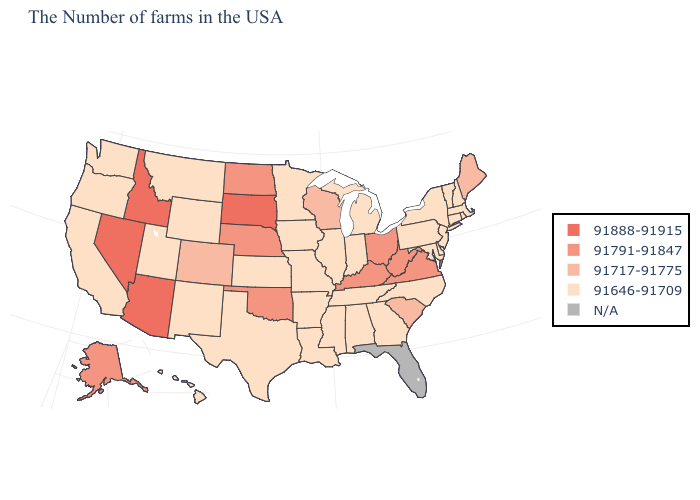Among the states that border Indiana , does Ohio have the highest value?
Quick response, please. Yes. Name the states that have a value in the range 91717-91775?
Answer briefly. Maine, South Carolina, Wisconsin, Colorado. Name the states that have a value in the range 91888-91915?
Quick response, please. South Dakota, Arizona, Idaho, Nevada. Among the states that border Minnesota , does Wisconsin have the lowest value?
Keep it brief. No. Which states hav the highest value in the Northeast?
Give a very brief answer. Maine. What is the highest value in the USA?
Keep it brief. 91888-91915. What is the value of Iowa?
Quick response, please. 91646-91709. Name the states that have a value in the range 91646-91709?
Write a very short answer. Massachusetts, Rhode Island, New Hampshire, Vermont, Connecticut, New York, New Jersey, Delaware, Maryland, Pennsylvania, North Carolina, Georgia, Michigan, Indiana, Alabama, Tennessee, Illinois, Mississippi, Louisiana, Missouri, Arkansas, Minnesota, Iowa, Kansas, Texas, Wyoming, New Mexico, Utah, Montana, California, Washington, Oregon, Hawaii. Does Nevada have the lowest value in the USA?
Give a very brief answer. No. What is the value of North Dakota?
Keep it brief. 91791-91847. Which states have the lowest value in the South?
Concise answer only. Delaware, Maryland, North Carolina, Georgia, Alabama, Tennessee, Mississippi, Louisiana, Arkansas, Texas. Which states hav the highest value in the MidWest?
Concise answer only. South Dakota. Which states hav the highest value in the South?
Give a very brief answer. Virginia, West Virginia, Kentucky, Oklahoma. What is the highest value in the USA?
Give a very brief answer. 91888-91915. 